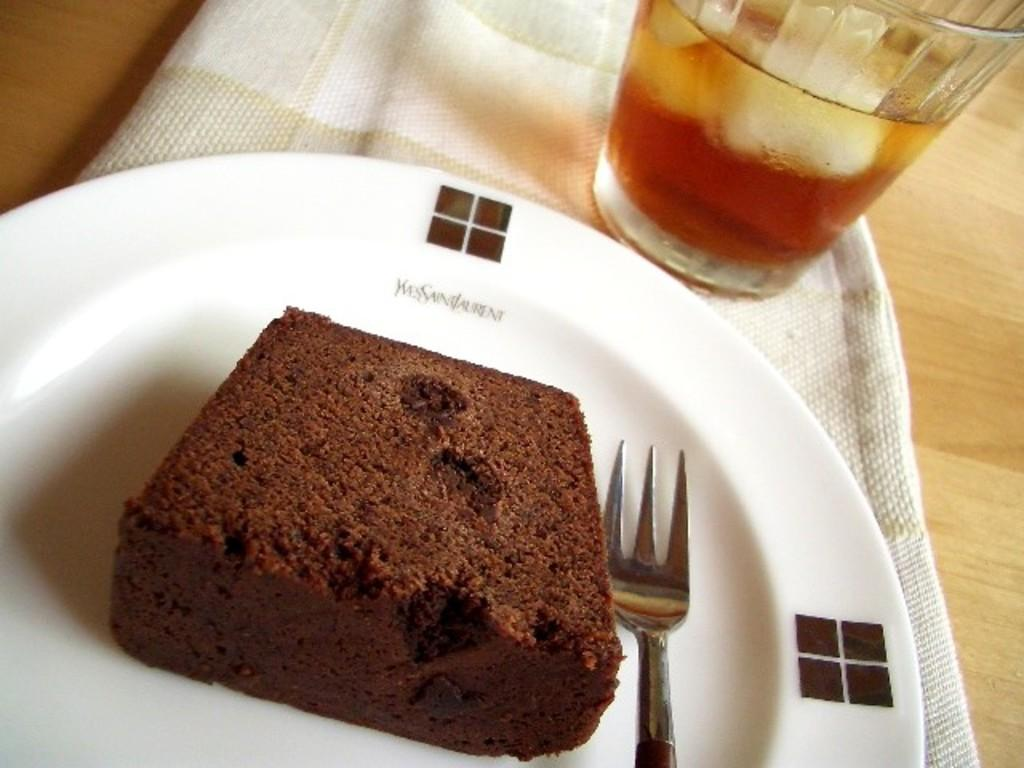What type of dessert is visible in the image? There is a brownie in the image. What utensil is placed on the white plate in the image? There is a fork on a white plate in the image. What type of beverage might be in the glass in the image? There is a glass of drink in the image, but the specific type of drink is not mentioned. What is covering the table in the image? There is a cloth on a table in the image. How does the wind affect the brownie in the image? There is no wind present in the image, so it does not affect the brownie. What type of tools might a carpenter use in the image? There are no carpentry tools or a carpenter present in the image. Can you see a rabbit in the image? There is no rabbit present in the image. 